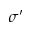Convert formula to latex. <formula><loc_0><loc_0><loc_500><loc_500>\sigma ^ { \prime }</formula> 